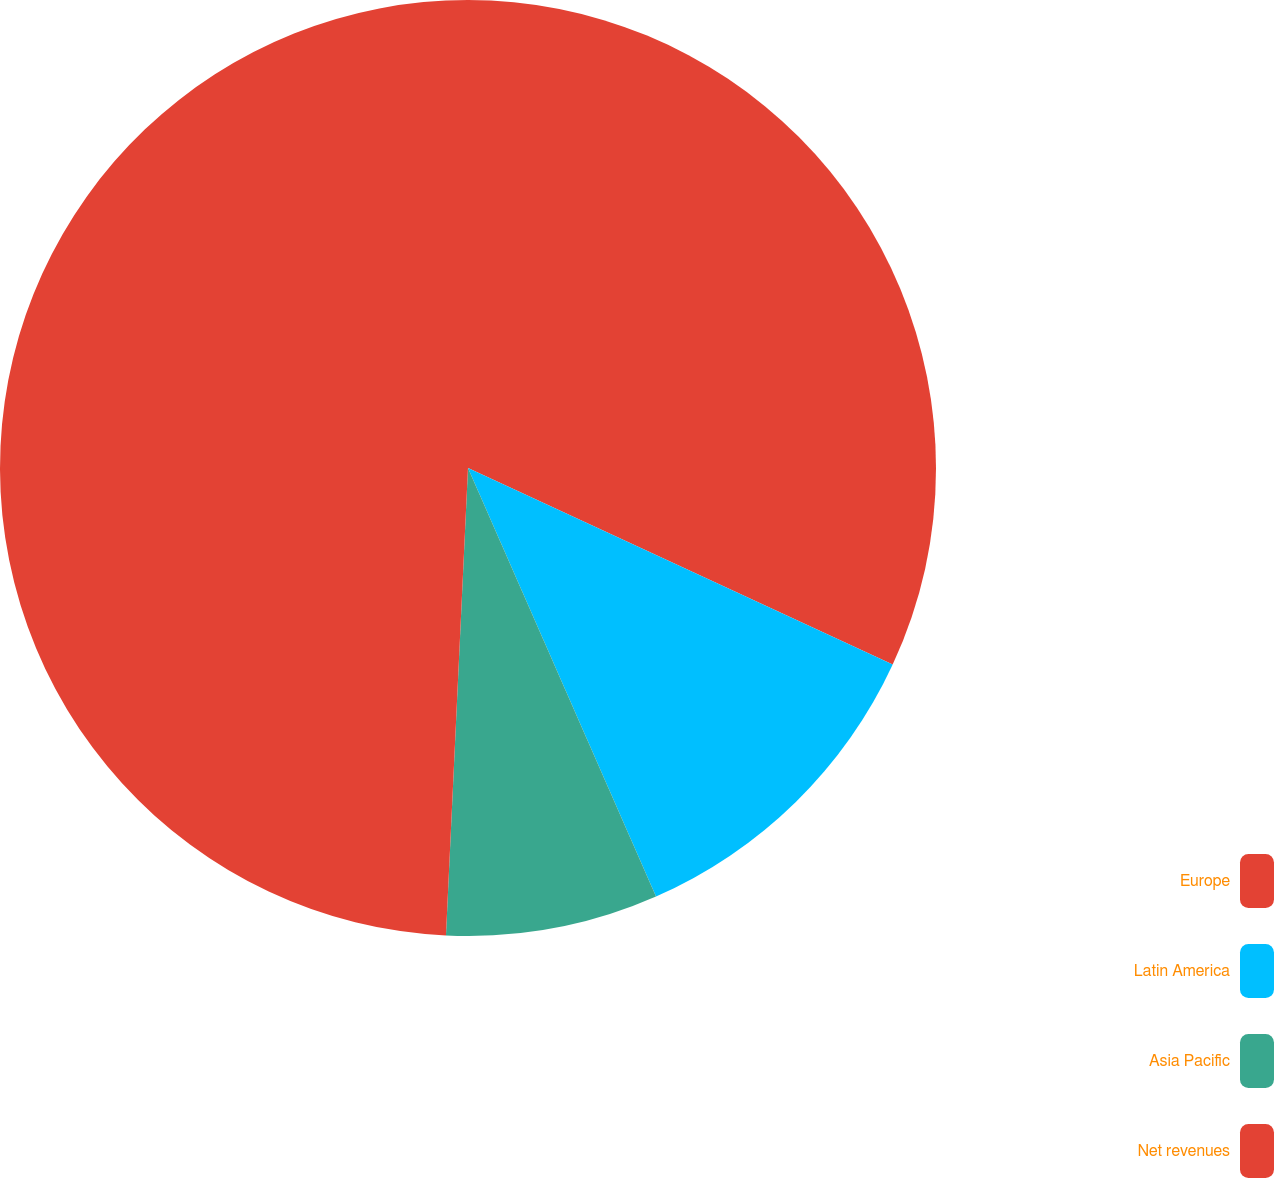Convert chart to OTSL. <chart><loc_0><loc_0><loc_500><loc_500><pie_chart><fcel>Europe<fcel>Latin America<fcel>Asia Pacific<fcel>Net revenues<nl><fcel>31.9%<fcel>11.52%<fcel>7.33%<fcel>49.25%<nl></chart> 